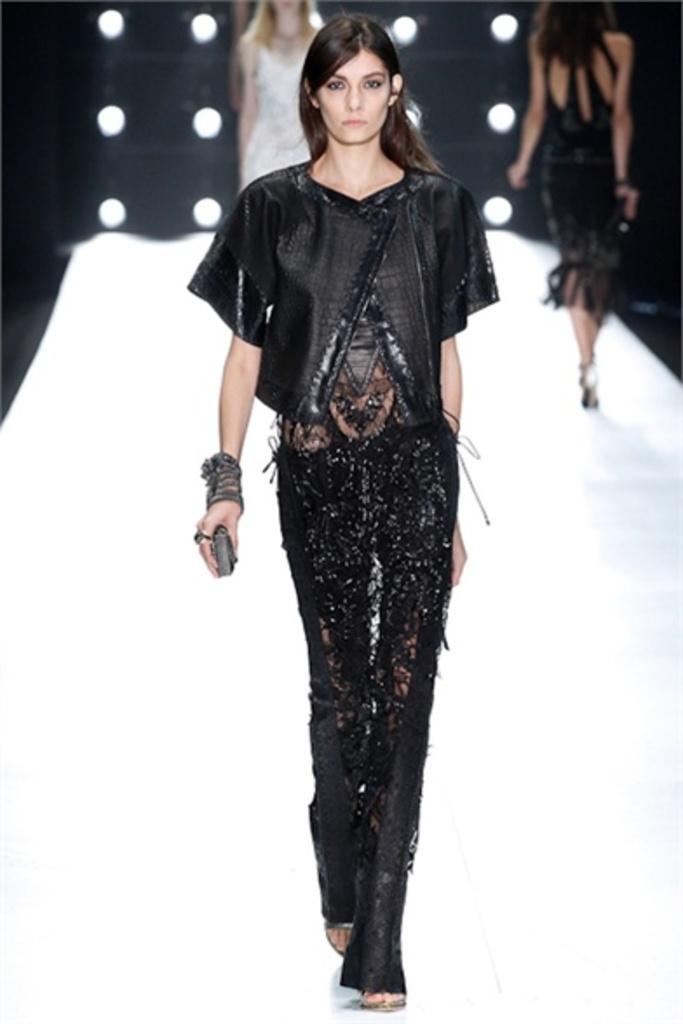Can you describe this image briefly? In this picture few woman walking on the dais. Looks like a fashion show and I can see lights on the back. 